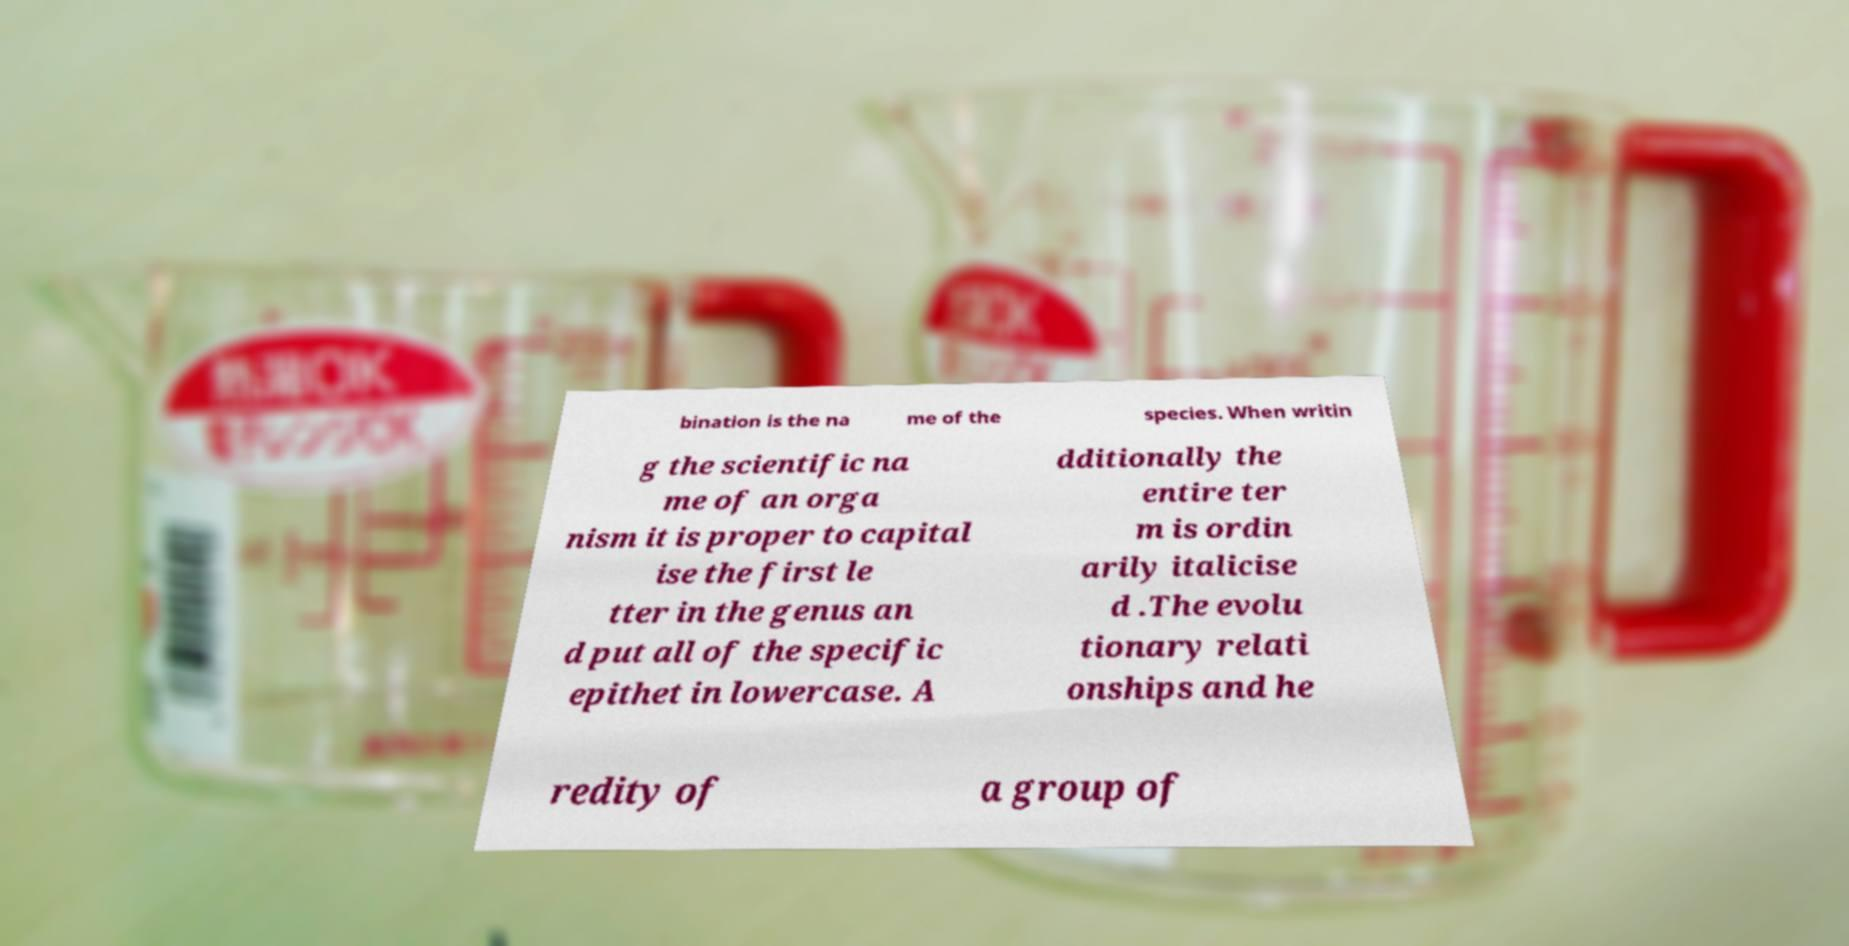Please identify and transcribe the text found in this image. bination is the na me of the species. When writin g the scientific na me of an orga nism it is proper to capital ise the first le tter in the genus an d put all of the specific epithet in lowercase. A dditionally the entire ter m is ordin arily italicise d .The evolu tionary relati onships and he redity of a group of 